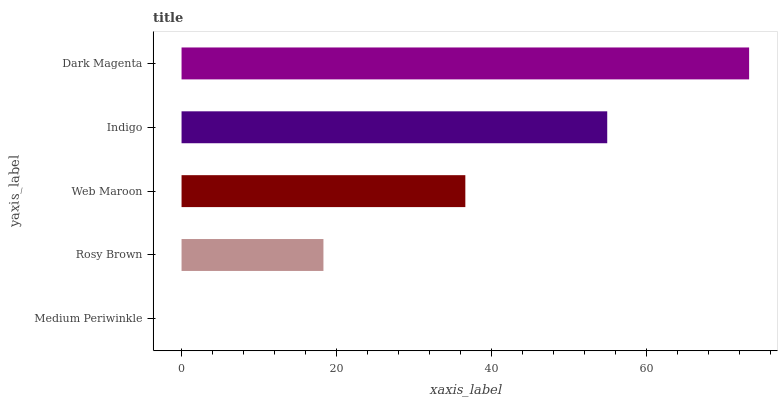Is Medium Periwinkle the minimum?
Answer yes or no. Yes. Is Dark Magenta the maximum?
Answer yes or no. Yes. Is Rosy Brown the minimum?
Answer yes or no. No. Is Rosy Brown the maximum?
Answer yes or no. No. Is Rosy Brown greater than Medium Periwinkle?
Answer yes or no. Yes. Is Medium Periwinkle less than Rosy Brown?
Answer yes or no. Yes. Is Medium Periwinkle greater than Rosy Brown?
Answer yes or no. No. Is Rosy Brown less than Medium Periwinkle?
Answer yes or no. No. Is Web Maroon the high median?
Answer yes or no. Yes. Is Web Maroon the low median?
Answer yes or no. Yes. Is Rosy Brown the high median?
Answer yes or no. No. Is Dark Magenta the low median?
Answer yes or no. No. 